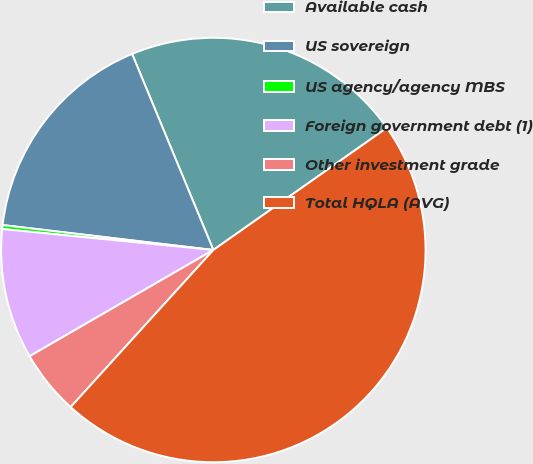Convert chart to OTSL. <chart><loc_0><loc_0><loc_500><loc_500><pie_chart><fcel>Available cash<fcel>US sovereign<fcel>US agency/agency MBS<fcel>Foreign government debt (1)<fcel>Other investment grade<fcel>Total HQLA (AVG)<nl><fcel>21.49%<fcel>16.87%<fcel>0.3%<fcel>9.92%<fcel>4.92%<fcel>46.5%<nl></chart> 